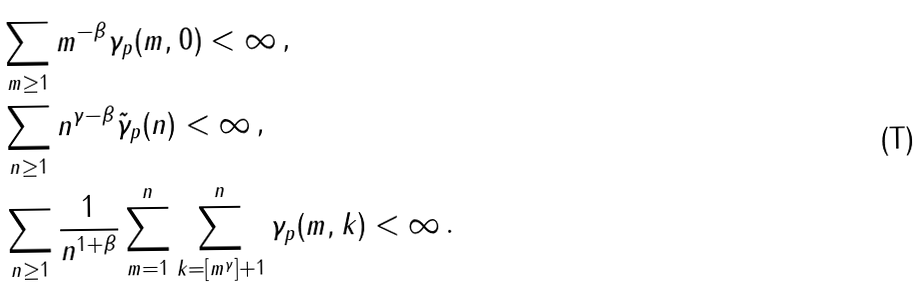<formula> <loc_0><loc_0><loc_500><loc_500>& \sum _ { m \geq 1 } m ^ { - \beta } \gamma _ { p } ( m , 0 ) < \infty \, , \\ & \sum _ { n \geq 1 } n ^ { \gamma - \beta } \tilde { \gamma } _ { p } ( n ) < \infty \, , \\ & \sum _ { n \geq 1 } \frac { 1 } { n ^ { 1 + \beta } } \sum _ { m = 1 } ^ { n } \sum _ { k = [ m ^ { \gamma } ] + 1 } ^ { n } \gamma _ { p } ( m , k ) < \infty \, .</formula> 